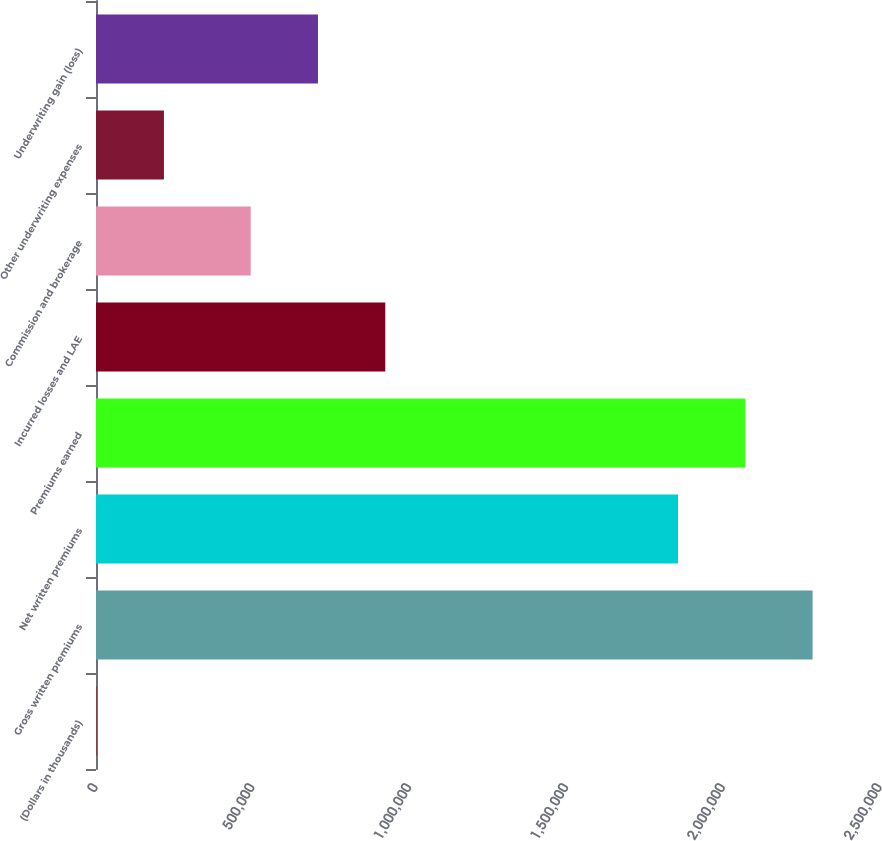Convert chart to OTSL. <chart><loc_0><loc_0><loc_500><loc_500><bar_chart><fcel>(Dollars in thousands)<fcel>Gross written premiums<fcel>Net written premiums<fcel>Premiums earned<fcel>Incurred losses and LAE<fcel>Commission and brokerage<fcel>Other underwriting expenses<fcel>Underwriting gain (loss)<nl><fcel>2015<fcel>2.28503e+06<fcel>1.85585e+06<fcel>2.07044e+06<fcel>922436<fcel>493261<fcel>216603<fcel>707849<nl></chart> 